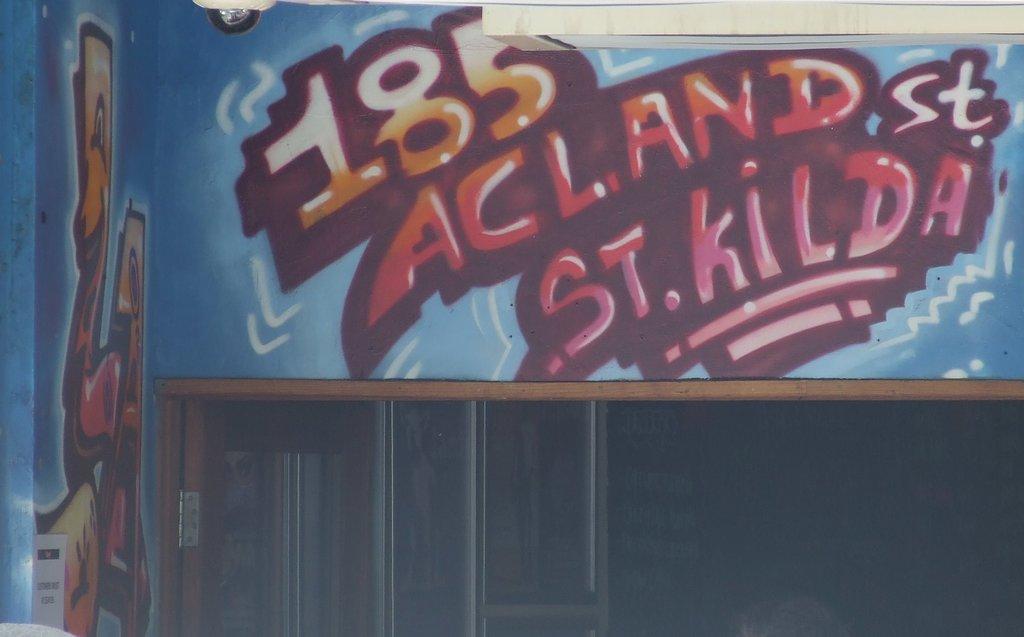What is painted on the wall?
Your answer should be very brief. 185 acland st st. kilda. What st is named?
Provide a short and direct response. Kilda. 